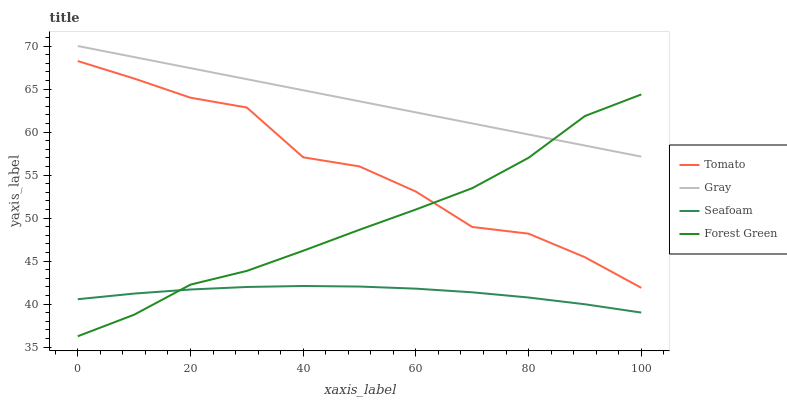Does Seafoam have the minimum area under the curve?
Answer yes or no. Yes. Does Gray have the maximum area under the curve?
Answer yes or no. Yes. Does Forest Green have the minimum area under the curve?
Answer yes or no. No. Does Forest Green have the maximum area under the curve?
Answer yes or no. No. Is Gray the smoothest?
Answer yes or no. Yes. Is Tomato the roughest?
Answer yes or no. Yes. Is Forest Green the smoothest?
Answer yes or no. No. Is Forest Green the roughest?
Answer yes or no. No. Does Forest Green have the lowest value?
Answer yes or no. Yes. Does Gray have the lowest value?
Answer yes or no. No. Does Gray have the highest value?
Answer yes or no. Yes. Does Forest Green have the highest value?
Answer yes or no. No. Is Tomato less than Gray?
Answer yes or no. Yes. Is Gray greater than Seafoam?
Answer yes or no. Yes. Does Forest Green intersect Seafoam?
Answer yes or no. Yes. Is Forest Green less than Seafoam?
Answer yes or no. No. Is Forest Green greater than Seafoam?
Answer yes or no. No. Does Tomato intersect Gray?
Answer yes or no. No. 